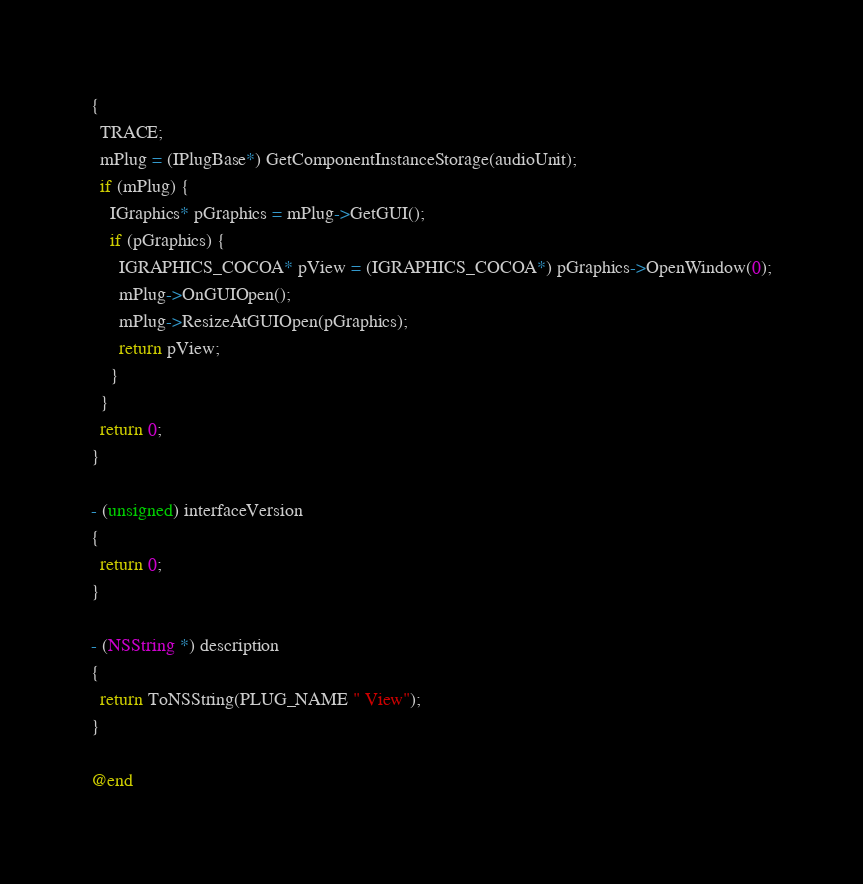<code> <loc_0><loc_0><loc_500><loc_500><_ObjectiveC_>{
  TRACE;
  mPlug = (IPlugBase*) GetComponentInstanceStorage(audioUnit);
  if (mPlug) {
    IGraphics* pGraphics = mPlug->GetGUI();   
    if (pGraphics) {
      IGRAPHICS_COCOA* pView = (IGRAPHICS_COCOA*) pGraphics->OpenWindow(0);
      mPlug->OnGUIOpen();
	  mPlug->ResizeAtGUIOpen(pGraphics);
      return pView;
    }
  }
  return 0; 
}

- (unsigned) interfaceVersion
{
  return 0;
}

- (NSString *) description
{
  return ToNSString(PLUG_NAME " View");
}

@end


</code> 